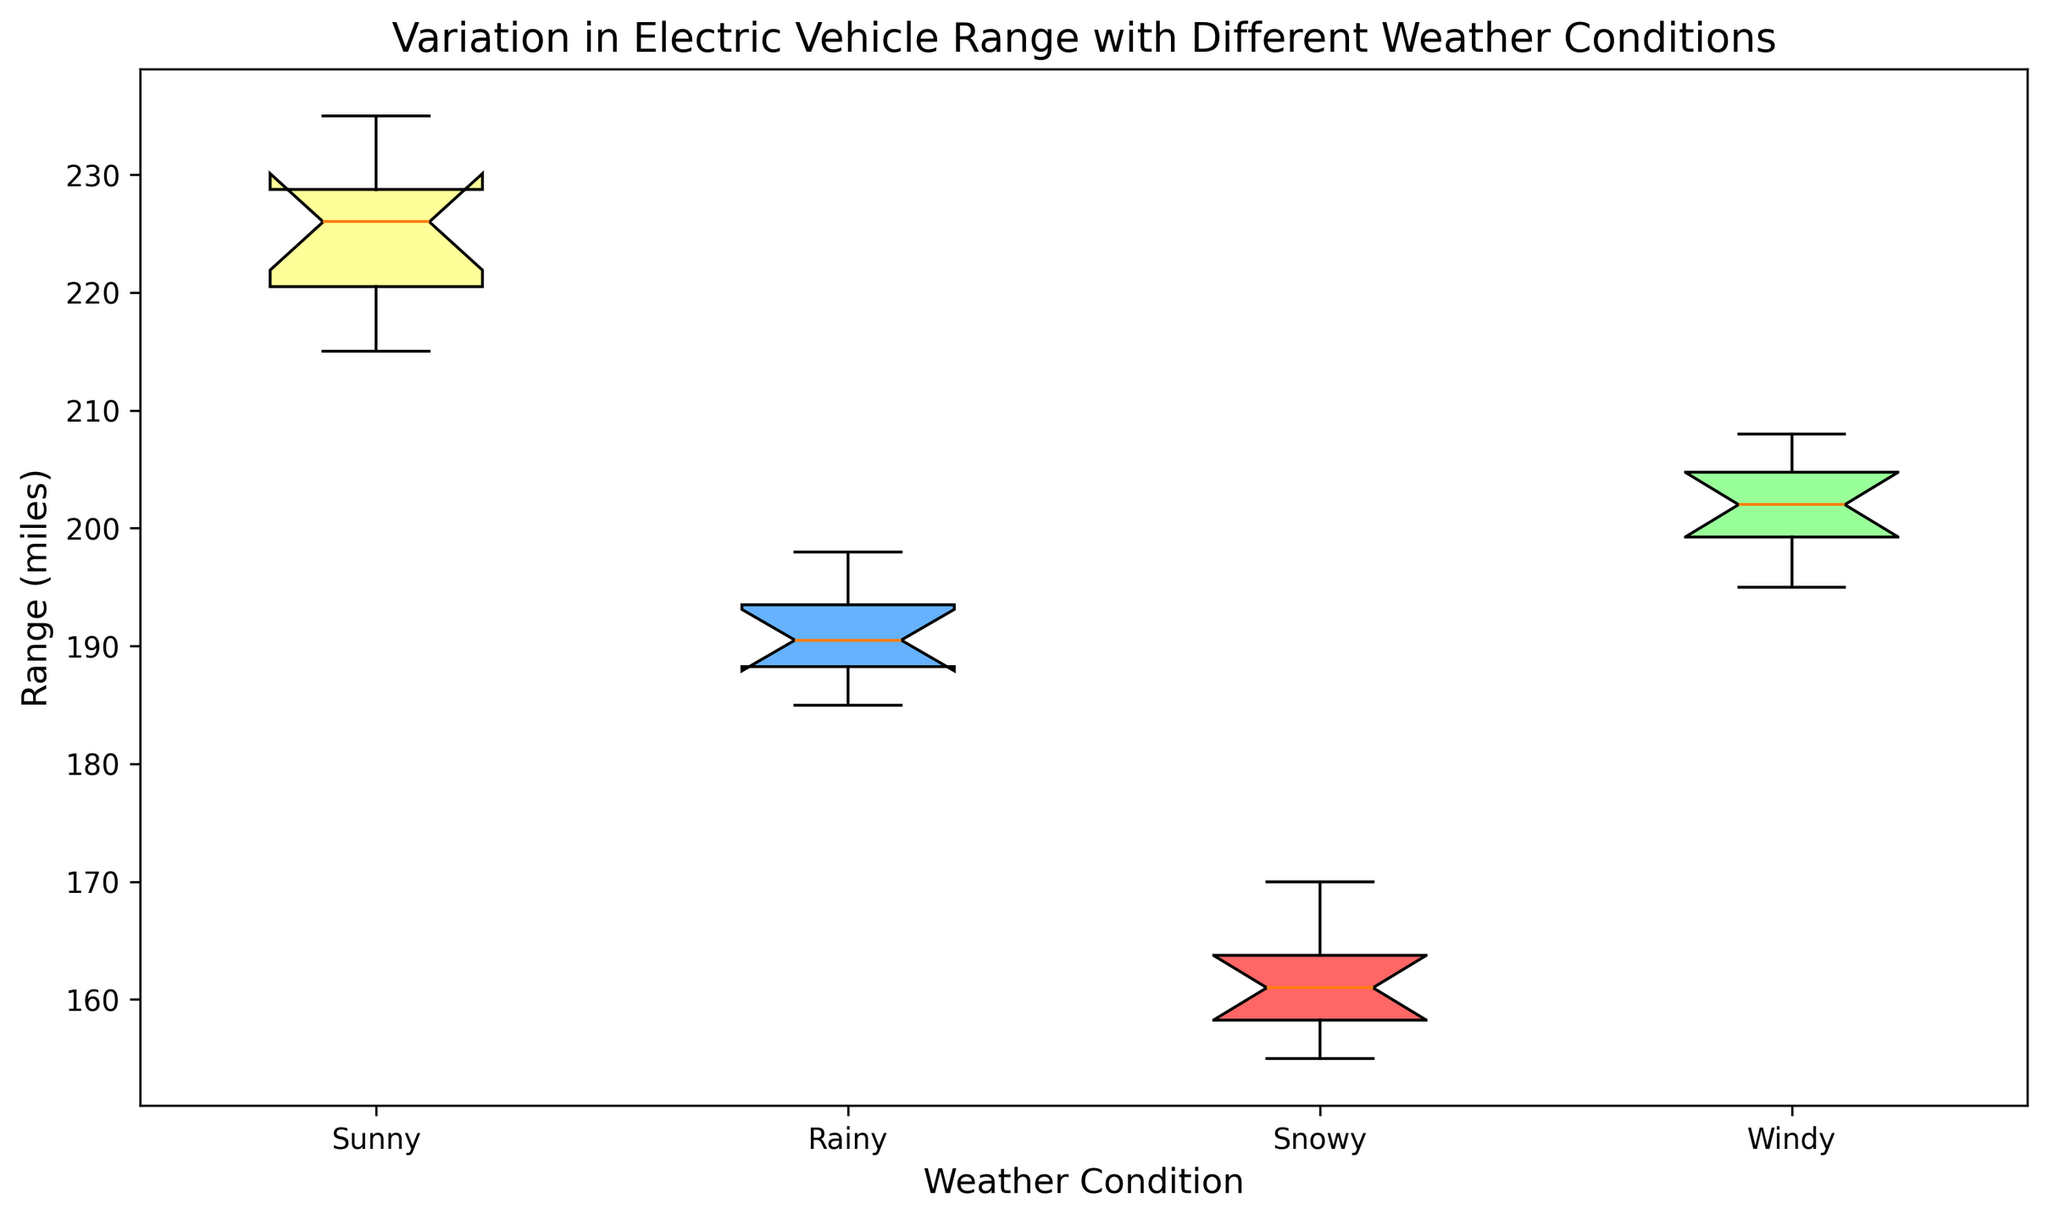What is the median range on sunny days? To find the median range on sunny days, we need to determine the middle value of the ordered data points for sunny days. The ordered data points are [215, 219, 220, 222, 225, 227, 228, 229, 230, 235]. The middle value is between 225 and 227, which is (225+227)/2 = 226.
Answer: 226 Which weather condition has the highest median range? We compare the median ranges of all weather conditions. From the boxplot, we can see that the median ranges are: Sunny (226), Rainy (190), Snowy (160), and Windy (202). The highest median range is on sunny days.
Answer: Sunny How does the range vary between snowy and windy conditions? We compare the boxplots for snowy and windy conditions. Snowy conditions have a lower median and a smaller IQR (155-170) compared to windy conditions, which have a higher median and a larger IQR (195-208). The range in snowy conditions is generally lower and more condensed.
Answer: Snowy conditions have a lower and more condensed range What are the colors of the boxes used for the different weather conditions? We observe the colors of the boxes representing different weather conditions. The box for sunny is yellow, for rainy is blue, for snowy is red, and for windy is green.
Answer: Sunny: yellow, Rainy: blue, Snowy: red, Windy: green Which weather condition shows the largest interquartile range (IQR)? The IQR is the difference between the third quartile (Q3) and the first quartile (Q1) for each condition. From the boxplot, Windy has the largest IQR because the box extends wider compared to the other conditions.
Answer: Windy Is there any overlap between the ranges of snowy and rainy conditions? We observe the boxplots for snowy and rainy conditions. The highest value for snowy (170) is less than the lowest value for rainy (185), indicating no overlap.
Answer: No What is the difference between the maximum ranges of sunny and snowy conditions? The maximum range for sunny is 235 and for snowy is 170. The difference is 235 - 170 = 65.
Answer: 65 Which condition shows the most variability in the electric vehicle range? Variability can be judged by the spread and length of the whiskers and the IQR. Windy conditions show the most variability as it has the widest spread.
Answer: Windy 